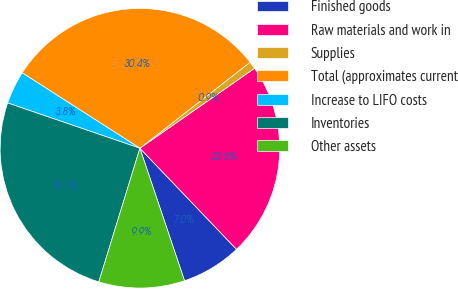Convert chart to OTSL. <chart><loc_0><loc_0><loc_500><loc_500><pie_chart><fcel>Finished goods<fcel>Raw materials and work in<fcel>Supplies<fcel>Total (approximates current<fcel>Increase to LIFO costs<fcel>Inventories<fcel>Other assets<nl><fcel>6.97%<fcel>22.55%<fcel>0.86%<fcel>30.38%<fcel>3.82%<fcel>25.5%<fcel>9.92%<nl></chart> 